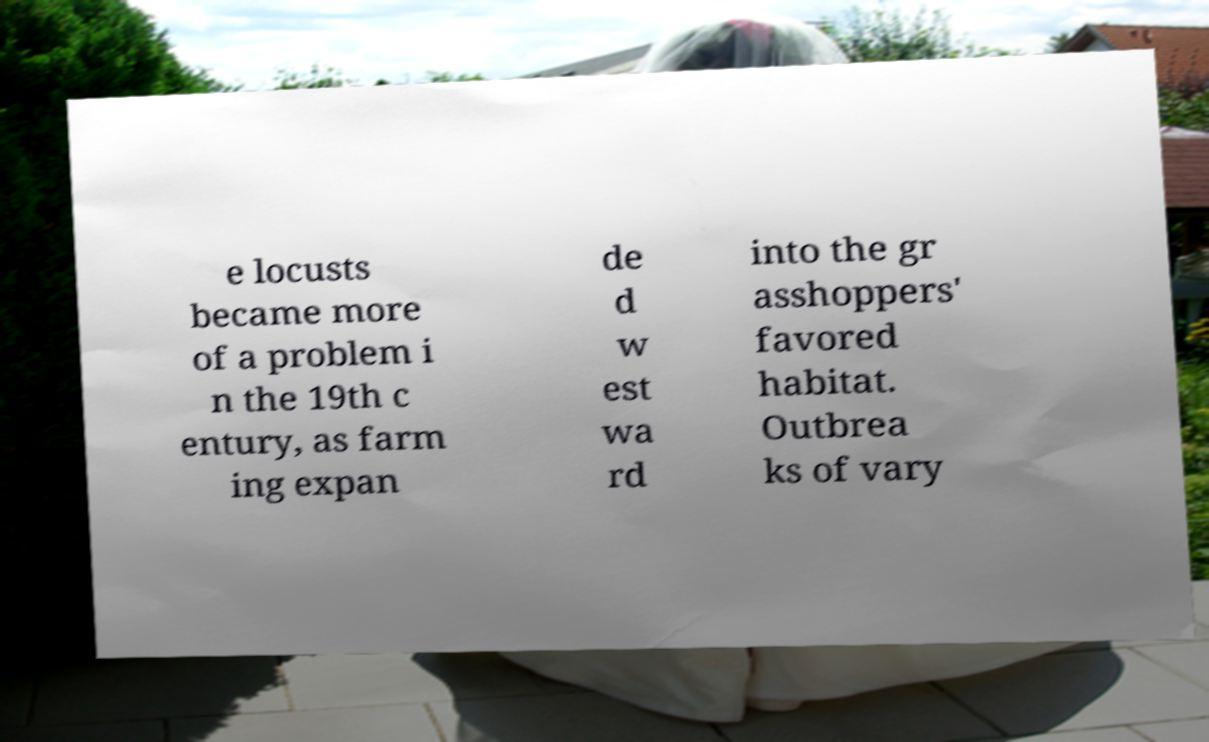Please identify and transcribe the text found in this image. e locusts became more of a problem i n the 19th c entury, as farm ing expan de d w est wa rd into the gr asshoppers' favored habitat. Outbrea ks of vary 